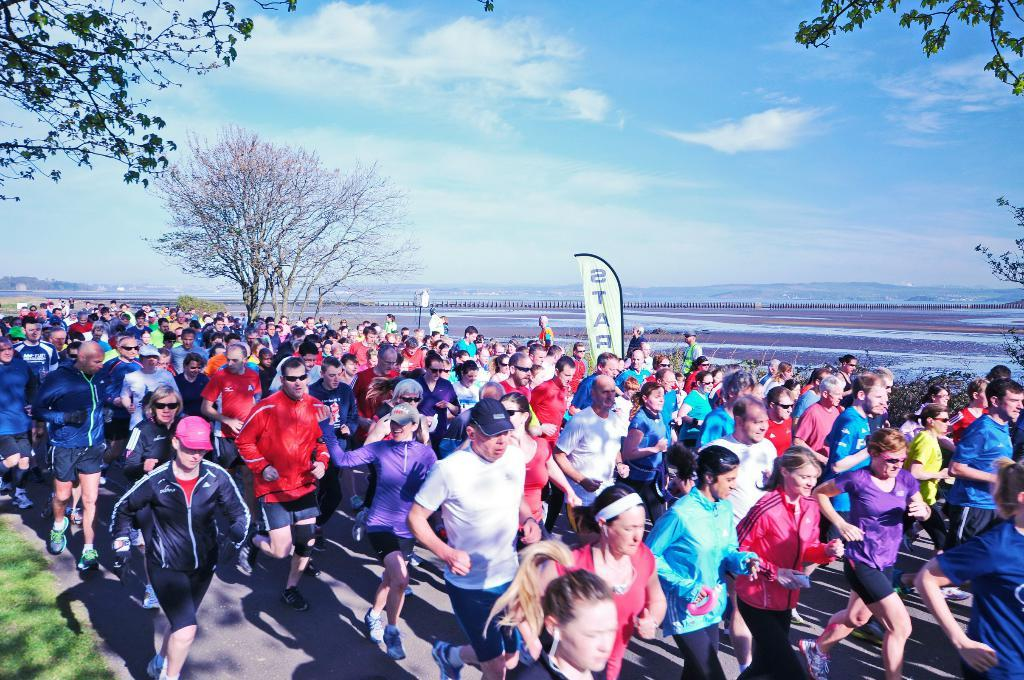What are the people in the image doing? The people in the image are walking on the road. What type of vegetation can be seen in the image? There is grass and trees visible in the image. What is hanging or displayed in the image? There is a banner in the image. What can be seen in the background of the image? There are hills and the sky visible in the background of the image. What is the condition of the sky in the image? The sky is visible with clouds present in the background of the image. What type of power is being generated by the people walking in the image? There is no indication of power generation in the image; the people are simply walking on the road. How many feet are visible in the image? The number of feet visible in the image cannot be determined, as the focus is on the people walking, not their feet. 